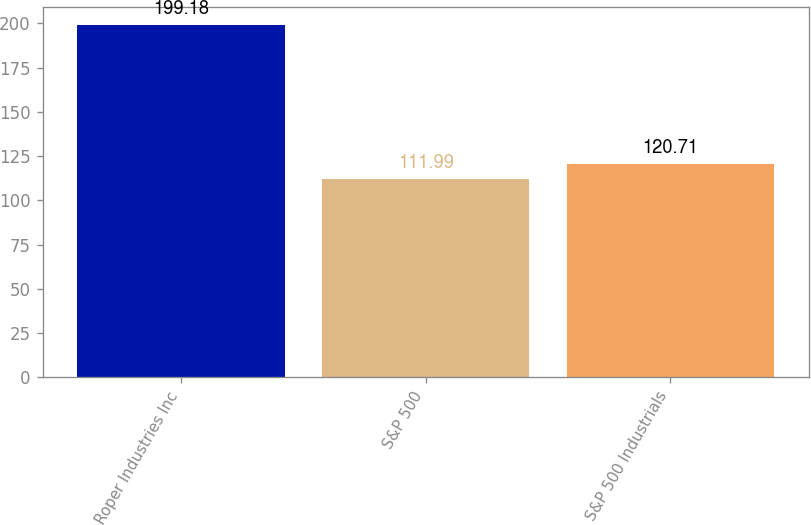Convert chart to OTSL. <chart><loc_0><loc_0><loc_500><loc_500><bar_chart><fcel>Roper Industries Inc<fcel>S&P 500<fcel>S&P 500 Industrials<nl><fcel>199.18<fcel>111.99<fcel>120.71<nl></chart> 